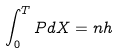<formula> <loc_0><loc_0><loc_500><loc_500>\int _ { 0 } ^ { T } P d X = n h</formula> 